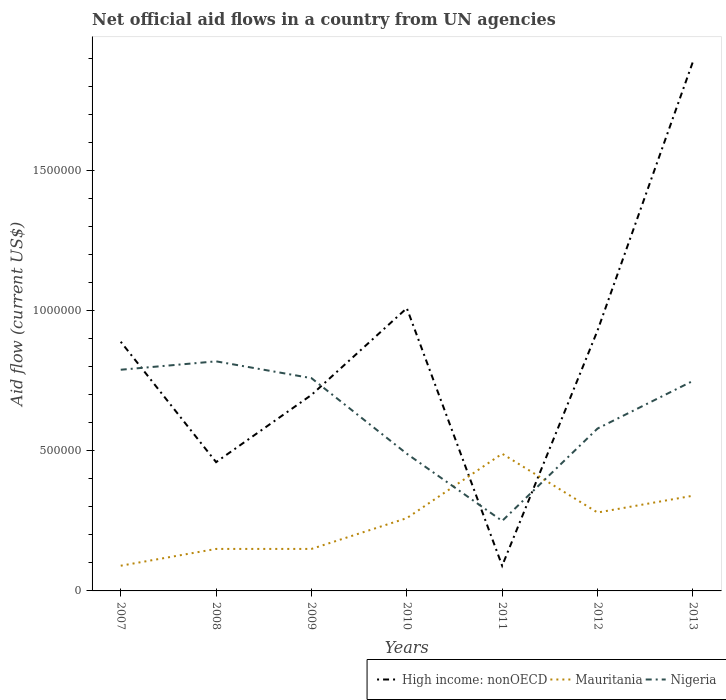How many different coloured lines are there?
Provide a succinct answer. 3. What is the total net official aid flow in Nigeria in the graph?
Offer a terse response. 5.10e+05. What is the difference between the highest and the second highest net official aid flow in High income: nonOECD?
Ensure brevity in your answer.  1.80e+06. What is the difference between the highest and the lowest net official aid flow in Mauritania?
Your answer should be very brief. 4. How many years are there in the graph?
Provide a short and direct response. 7. What is the difference between two consecutive major ticks on the Y-axis?
Provide a succinct answer. 5.00e+05. Does the graph contain any zero values?
Offer a terse response. No. Where does the legend appear in the graph?
Make the answer very short. Bottom right. How are the legend labels stacked?
Give a very brief answer. Horizontal. What is the title of the graph?
Your answer should be compact. Net official aid flows in a country from UN agencies. Does "South Africa" appear as one of the legend labels in the graph?
Your response must be concise. No. What is the label or title of the Y-axis?
Keep it short and to the point. Aid flow (current US$). What is the Aid flow (current US$) in High income: nonOECD in 2007?
Make the answer very short. 8.90e+05. What is the Aid flow (current US$) in Mauritania in 2007?
Offer a terse response. 9.00e+04. What is the Aid flow (current US$) in Nigeria in 2007?
Your answer should be very brief. 7.90e+05. What is the Aid flow (current US$) in Nigeria in 2008?
Provide a succinct answer. 8.20e+05. What is the Aid flow (current US$) in Mauritania in 2009?
Provide a succinct answer. 1.50e+05. What is the Aid flow (current US$) of Nigeria in 2009?
Your answer should be compact. 7.60e+05. What is the Aid flow (current US$) in High income: nonOECD in 2010?
Ensure brevity in your answer.  1.01e+06. What is the Aid flow (current US$) in Nigeria in 2010?
Your response must be concise. 4.90e+05. What is the Aid flow (current US$) in High income: nonOECD in 2011?
Your answer should be very brief. 9.00e+04. What is the Aid flow (current US$) in Nigeria in 2011?
Make the answer very short. 2.50e+05. What is the Aid flow (current US$) in High income: nonOECD in 2012?
Offer a very short reply. 9.30e+05. What is the Aid flow (current US$) of Nigeria in 2012?
Offer a very short reply. 5.80e+05. What is the Aid flow (current US$) of High income: nonOECD in 2013?
Keep it short and to the point. 1.89e+06. What is the Aid flow (current US$) of Mauritania in 2013?
Provide a succinct answer. 3.40e+05. What is the Aid flow (current US$) of Nigeria in 2013?
Offer a terse response. 7.50e+05. Across all years, what is the maximum Aid flow (current US$) of High income: nonOECD?
Make the answer very short. 1.89e+06. Across all years, what is the maximum Aid flow (current US$) in Mauritania?
Ensure brevity in your answer.  4.90e+05. Across all years, what is the maximum Aid flow (current US$) of Nigeria?
Provide a short and direct response. 8.20e+05. Across all years, what is the minimum Aid flow (current US$) of Nigeria?
Ensure brevity in your answer.  2.50e+05. What is the total Aid flow (current US$) of High income: nonOECD in the graph?
Your answer should be compact. 5.97e+06. What is the total Aid flow (current US$) of Mauritania in the graph?
Offer a very short reply. 1.76e+06. What is the total Aid flow (current US$) in Nigeria in the graph?
Keep it short and to the point. 4.44e+06. What is the difference between the Aid flow (current US$) of Mauritania in 2007 and that in 2008?
Your answer should be compact. -6.00e+04. What is the difference between the Aid flow (current US$) of Nigeria in 2007 and that in 2008?
Make the answer very short. -3.00e+04. What is the difference between the Aid flow (current US$) in High income: nonOECD in 2007 and that in 2009?
Give a very brief answer. 1.90e+05. What is the difference between the Aid flow (current US$) of Mauritania in 2007 and that in 2009?
Provide a short and direct response. -6.00e+04. What is the difference between the Aid flow (current US$) in High income: nonOECD in 2007 and that in 2010?
Provide a short and direct response. -1.20e+05. What is the difference between the Aid flow (current US$) in Mauritania in 2007 and that in 2010?
Offer a terse response. -1.70e+05. What is the difference between the Aid flow (current US$) of Mauritania in 2007 and that in 2011?
Provide a short and direct response. -4.00e+05. What is the difference between the Aid flow (current US$) of Nigeria in 2007 and that in 2011?
Your answer should be compact. 5.40e+05. What is the difference between the Aid flow (current US$) in High income: nonOECD in 2007 and that in 2012?
Offer a terse response. -4.00e+04. What is the difference between the Aid flow (current US$) in Mauritania in 2007 and that in 2013?
Ensure brevity in your answer.  -2.50e+05. What is the difference between the Aid flow (current US$) of Nigeria in 2008 and that in 2009?
Your answer should be compact. 6.00e+04. What is the difference between the Aid flow (current US$) in High income: nonOECD in 2008 and that in 2010?
Provide a succinct answer. -5.50e+05. What is the difference between the Aid flow (current US$) in Nigeria in 2008 and that in 2011?
Offer a terse response. 5.70e+05. What is the difference between the Aid flow (current US$) in High income: nonOECD in 2008 and that in 2012?
Ensure brevity in your answer.  -4.70e+05. What is the difference between the Aid flow (current US$) in Nigeria in 2008 and that in 2012?
Your answer should be compact. 2.40e+05. What is the difference between the Aid flow (current US$) of High income: nonOECD in 2008 and that in 2013?
Provide a short and direct response. -1.43e+06. What is the difference between the Aid flow (current US$) in Mauritania in 2008 and that in 2013?
Your answer should be compact. -1.90e+05. What is the difference between the Aid flow (current US$) in Nigeria in 2008 and that in 2013?
Your answer should be compact. 7.00e+04. What is the difference between the Aid flow (current US$) of High income: nonOECD in 2009 and that in 2010?
Give a very brief answer. -3.10e+05. What is the difference between the Aid flow (current US$) in Mauritania in 2009 and that in 2010?
Your response must be concise. -1.10e+05. What is the difference between the Aid flow (current US$) of Nigeria in 2009 and that in 2010?
Offer a very short reply. 2.70e+05. What is the difference between the Aid flow (current US$) of High income: nonOECD in 2009 and that in 2011?
Provide a short and direct response. 6.10e+05. What is the difference between the Aid flow (current US$) of Nigeria in 2009 and that in 2011?
Ensure brevity in your answer.  5.10e+05. What is the difference between the Aid flow (current US$) in High income: nonOECD in 2009 and that in 2013?
Ensure brevity in your answer.  -1.19e+06. What is the difference between the Aid flow (current US$) in Nigeria in 2009 and that in 2013?
Offer a very short reply. 10000. What is the difference between the Aid flow (current US$) of High income: nonOECD in 2010 and that in 2011?
Offer a very short reply. 9.20e+05. What is the difference between the Aid flow (current US$) in Mauritania in 2010 and that in 2011?
Your answer should be compact. -2.30e+05. What is the difference between the Aid flow (current US$) of High income: nonOECD in 2010 and that in 2012?
Your answer should be compact. 8.00e+04. What is the difference between the Aid flow (current US$) of High income: nonOECD in 2010 and that in 2013?
Offer a very short reply. -8.80e+05. What is the difference between the Aid flow (current US$) in Mauritania in 2010 and that in 2013?
Your answer should be compact. -8.00e+04. What is the difference between the Aid flow (current US$) of Nigeria in 2010 and that in 2013?
Offer a very short reply. -2.60e+05. What is the difference between the Aid flow (current US$) in High income: nonOECD in 2011 and that in 2012?
Offer a terse response. -8.40e+05. What is the difference between the Aid flow (current US$) of Mauritania in 2011 and that in 2012?
Your answer should be compact. 2.10e+05. What is the difference between the Aid flow (current US$) of Nigeria in 2011 and that in 2012?
Your response must be concise. -3.30e+05. What is the difference between the Aid flow (current US$) of High income: nonOECD in 2011 and that in 2013?
Offer a very short reply. -1.80e+06. What is the difference between the Aid flow (current US$) of Nigeria in 2011 and that in 2013?
Your response must be concise. -5.00e+05. What is the difference between the Aid flow (current US$) in High income: nonOECD in 2012 and that in 2013?
Keep it short and to the point. -9.60e+05. What is the difference between the Aid flow (current US$) of High income: nonOECD in 2007 and the Aid flow (current US$) of Mauritania in 2008?
Offer a terse response. 7.40e+05. What is the difference between the Aid flow (current US$) of Mauritania in 2007 and the Aid flow (current US$) of Nigeria in 2008?
Offer a very short reply. -7.30e+05. What is the difference between the Aid flow (current US$) of High income: nonOECD in 2007 and the Aid flow (current US$) of Mauritania in 2009?
Ensure brevity in your answer.  7.40e+05. What is the difference between the Aid flow (current US$) in High income: nonOECD in 2007 and the Aid flow (current US$) in Nigeria in 2009?
Provide a succinct answer. 1.30e+05. What is the difference between the Aid flow (current US$) of Mauritania in 2007 and the Aid flow (current US$) of Nigeria in 2009?
Provide a succinct answer. -6.70e+05. What is the difference between the Aid flow (current US$) of High income: nonOECD in 2007 and the Aid flow (current US$) of Mauritania in 2010?
Ensure brevity in your answer.  6.30e+05. What is the difference between the Aid flow (current US$) in Mauritania in 2007 and the Aid flow (current US$) in Nigeria in 2010?
Keep it short and to the point. -4.00e+05. What is the difference between the Aid flow (current US$) of High income: nonOECD in 2007 and the Aid flow (current US$) of Mauritania in 2011?
Provide a succinct answer. 4.00e+05. What is the difference between the Aid flow (current US$) in High income: nonOECD in 2007 and the Aid flow (current US$) in Nigeria in 2011?
Your response must be concise. 6.40e+05. What is the difference between the Aid flow (current US$) of Mauritania in 2007 and the Aid flow (current US$) of Nigeria in 2012?
Your answer should be very brief. -4.90e+05. What is the difference between the Aid flow (current US$) of High income: nonOECD in 2007 and the Aid flow (current US$) of Nigeria in 2013?
Provide a short and direct response. 1.40e+05. What is the difference between the Aid flow (current US$) in Mauritania in 2007 and the Aid flow (current US$) in Nigeria in 2013?
Ensure brevity in your answer.  -6.60e+05. What is the difference between the Aid flow (current US$) in High income: nonOECD in 2008 and the Aid flow (current US$) in Mauritania in 2009?
Your answer should be very brief. 3.10e+05. What is the difference between the Aid flow (current US$) of Mauritania in 2008 and the Aid flow (current US$) of Nigeria in 2009?
Keep it short and to the point. -6.10e+05. What is the difference between the Aid flow (current US$) in High income: nonOECD in 2008 and the Aid flow (current US$) in Mauritania in 2010?
Your answer should be compact. 2.00e+05. What is the difference between the Aid flow (current US$) in Mauritania in 2008 and the Aid flow (current US$) in Nigeria in 2010?
Provide a succinct answer. -3.40e+05. What is the difference between the Aid flow (current US$) of High income: nonOECD in 2008 and the Aid flow (current US$) of Mauritania in 2011?
Offer a terse response. -3.00e+04. What is the difference between the Aid flow (current US$) of Mauritania in 2008 and the Aid flow (current US$) of Nigeria in 2011?
Ensure brevity in your answer.  -1.00e+05. What is the difference between the Aid flow (current US$) of Mauritania in 2008 and the Aid flow (current US$) of Nigeria in 2012?
Your response must be concise. -4.30e+05. What is the difference between the Aid flow (current US$) in High income: nonOECD in 2008 and the Aid flow (current US$) in Mauritania in 2013?
Your answer should be compact. 1.20e+05. What is the difference between the Aid flow (current US$) in High income: nonOECD in 2008 and the Aid flow (current US$) in Nigeria in 2013?
Your response must be concise. -2.90e+05. What is the difference between the Aid flow (current US$) in Mauritania in 2008 and the Aid flow (current US$) in Nigeria in 2013?
Ensure brevity in your answer.  -6.00e+05. What is the difference between the Aid flow (current US$) of High income: nonOECD in 2009 and the Aid flow (current US$) of Nigeria in 2010?
Keep it short and to the point. 2.10e+05. What is the difference between the Aid flow (current US$) of High income: nonOECD in 2009 and the Aid flow (current US$) of Mauritania in 2011?
Give a very brief answer. 2.10e+05. What is the difference between the Aid flow (current US$) of High income: nonOECD in 2009 and the Aid flow (current US$) of Mauritania in 2012?
Make the answer very short. 4.20e+05. What is the difference between the Aid flow (current US$) of High income: nonOECD in 2009 and the Aid flow (current US$) of Nigeria in 2012?
Provide a succinct answer. 1.20e+05. What is the difference between the Aid flow (current US$) in Mauritania in 2009 and the Aid flow (current US$) in Nigeria in 2012?
Your response must be concise. -4.30e+05. What is the difference between the Aid flow (current US$) in Mauritania in 2009 and the Aid flow (current US$) in Nigeria in 2013?
Provide a short and direct response. -6.00e+05. What is the difference between the Aid flow (current US$) of High income: nonOECD in 2010 and the Aid flow (current US$) of Mauritania in 2011?
Offer a terse response. 5.20e+05. What is the difference between the Aid flow (current US$) in High income: nonOECD in 2010 and the Aid flow (current US$) in Nigeria in 2011?
Your response must be concise. 7.60e+05. What is the difference between the Aid flow (current US$) of High income: nonOECD in 2010 and the Aid flow (current US$) of Mauritania in 2012?
Your answer should be very brief. 7.30e+05. What is the difference between the Aid flow (current US$) of High income: nonOECD in 2010 and the Aid flow (current US$) of Nigeria in 2012?
Provide a short and direct response. 4.30e+05. What is the difference between the Aid flow (current US$) of Mauritania in 2010 and the Aid flow (current US$) of Nigeria in 2012?
Provide a succinct answer. -3.20e+05. What is the difference between the Aid flow (current US$) of High income: nonOECD in 2010 and the Aid flow (current US$) of Mauritania in 2013?
Your answer should be very brief. 6.70e+05. What is the difference between the Aid flow (current US$) in Mauritania in 2010 and the Aid flow (current US$) in Nigeria in 2013?
Provide a short and direct response. -4.90e+05. What is the difference between the Aid flow (current US$) of High income: nonOECD in 2011 and the Aid flow (current US$) of Nigeria in 2012?
Provide a succinct answer. -4.90e+05. What is the difference between the Aid flow (current US$) in High income: nonOECD in 2011 and the Aid flow (current US$) in Nigeria in 2013?
Your answer should be compact. -6.60e+05. What is the difference between the Aid flow (current US$) of High income: nonOECD in 2012 and the Aid flow (current US$) of Mauritania in 2013?
Offer a terse response. 5.90e+05. What is the difference between the Aid flow (current US$) of High income: nonOECD in 2012 and the Aid flow (current US$) of Nigeria in 2013?
Provide a succinct answer. 1.80e+05. What is the difference between the Aid flow (current US$) in Mauritania in 2012 and the Aid flow (current US$) in Nigeria in 2013?
Make the answer very short. -4.70e+05. What is the average Aid flow (current US$) in High income: nonOECD per year?
Ensure brevity in your answer.  8.53e+05. What is the average Aid flow (current US$) of Mauritania per year?
Ensure brevity in your answer.  2.51e+05. What is the average Aid flow (current US$) of Nigeria per year?
Ensure brevity in your answer.  6.34e+05. In the year 2007, what is the difference between the Aid flow (current US$) of Mauritania and Aid flow (current US$) of Nigeria?
Make the answer very short. -7.00e+05. In the year 2008, what is the difference between the Aid flow (current US$) in High income: nonOECD and Aid flow (current US$) in Mauritania?
Your response must be concise. 3.10e+05. In the year 2008, what is the difference between the Aid flow (current US$) of High income: nonOECD and Aid flow (current US$) of Nigeria?
Your response must be concise. -3.60e+05. In the year 2008, what is the difference between the Aid flow (current US$) of Mauritania and Aid flow (current US$) of Nigeria?
Ensure brevity in your answer.  -6.70e+05. In the year 2009, what is the difference between the Aid flow (current US$) of Mauritania and Aid flow (current US$) of Nigeria?
Give a very brief answer. -6.10e+05. In the year 2010, what is the difference between the Aid flow (current US$) of High income: nonOECD and Aid flow (current US$) of Mauritania?
Keep it short and to the point. 7.50e+05. In the year 2010, what is the difference between the Aid flow (current US$) of High income: nonOECD and Aid flow (current US$) of Nigeria?
Ensure brevity in your answer.  5.20e+05. In the year 2011, what is the difference between the Aid flow (current US$) in High income: nonOECD and Aid flow (current US$) in Mauritania?
Provide a short and direct response. -4.00e+05. In the year 2011, what is the difference between the Aid flow (current US$) of High income: nonOECD and Aid flow (current US$) of Nigeria?
Make the answer very short. -1.60e+05. In the year 2012, what is the difference between the Aid flow (current US$) in High income: nonOECD and Aid flow (current US$) in Mauritania?
Offer a very short reply. 6.50e+05. In the year 2012, what is the difference between the Aid flow (current US$) in Mauritania and Aid flow (current US$) in Nigeria?
Offer a terse response. -3.00e+05. In the year 2013, what is the difference between the Aid flow (current US$) of High income: nonOECD and Aid flow (current US$) of Mauritania?
Ensure brevity in your answer.  1.55e+06. In the year 2013, what is the difference between the Aid flow (current US$) in High income: nonOECD and Aid flow (current US$) in Nigeria?
Your response must be concise. 1.14e+06. In the year 2013, what is the difference between the Aid flow (current US$) of Mauritania and Aid flow (current US$) of Nigeria?
Provide a succinct answer. -4.10e+05. What is the ratio of the Aid flow (current US$) in High income: nonOECD in 2007 to that in 2008?
Keep it short and to the point. 1.93. What is the ratio of the Aid flow (current US$) in Mauritania in 2007 to that in 2008?
Offer a very short reply. 0.6. What is the ratio of the Aid flow (current US$) in Nigeria in 2007 to that in 2008?
Your answer should be compact. 0.96. What is the ratio of the Aid flow (current US$) of High income: nonOECD in 2007 to that in 2009?
Ensure brevity in your answer.  1.27. What is the ratio of the Aid flow (current US$) in Mauritania in 2007 to that in 2009?
Keep it short and to the point. 0.6. What is the ratio of the Aid flow (current US$) of Nigeria in 2007 to that in 2009?
Make the answer very short. 1.04. What is the ratio of the Aid flow (current US$) of High income: nonOECD in 2007 to that in 2010?
Keep it short and to the point. 0.88. What is the ratio of the Aid flow (current US$) in Mauritania in 2007 to that in 2010?
Your answer should be very brief. 0.35. What is the ratio of the Aid flow (current US$) of Nigeria in 2007 to that in 2010?
Your response must be concise. 1.61. What is the ratio of the Aid flow (current US$) in High income: nonOECD in 2007 to that in 2011?
Make the answer very short. 9.89. What is the ratio of the Aid flow (current US$) of Mauritania in 2007 to that in 2011?
Offer a terse response. 0.18. What is the ratio of the Aid flow (current US$) in Nigeria in 2007 to that in 2011?
Make the answer very short. 3.16. What is the ratio of the Aid flow (current US$) of High income: nonOECD in 2007 to that in 2012?
Your response must be concise. 0.96. What is the ratio of the Aid flow (current US$) in Mauritania in 2007 to that in 2012?
Ensure brevity in your answer.  0.32. What is the ratio of the Aid flow (current US$) in Nigeria in 2007 to that in 2012?
Your response must be concise. 1.36. What is the ratio of the Aid flow (current US$) in High income: nonOECD in 2007 to that in 2013?
Provide a short and direct response. 0.47. What is the ratio of the Aid flow (current US$) in Mauritania in 2007 to that in 2013?
Your answer should be very brief. 0.26. What is the ratio of the Aid flow (current US$) in Nigeria in 2007 to that in 2013?
Your answer should be compact. 1.05. What is the ratio of the Aid flow (current US$) of High income: nonOECD in 2008 to that in 2009?
Give a very brief answer. 0.66. What is the ratio of the Aid flow (current US$) in Mauritania in 2008 to that in 2009?
Provide a succinct answer. 1. What is the ratio of the Aid flow (current US$) of Nigeria in 2008 to that in 2009?
Ensure brevity in your answer.  1.08. What is the ratio of the Aid flow (current US$) of High income: nonOECD in 2008 to that in 2010?
Give a very brief answer. 0.46. What is the ratio of the Aid flow (current US$) in Mauritania in 2008 to that in 2010?
Give a very brief answer. 0.58. What is the ratio of the Aid flow (current US$) in Nigeria in 2008 to that in 2010?
Your answer should be compact. 1.67. What is the ratio of the Aid flow (current US$) of High income: nonOECD in 2008 to that in 2011?
Your answer should be very brief. 5.11. What is the ratio of the Aid flow (current US$) in Mauritania in 2008 to that in 2011?
Provide a succinct answer. 0.31. What is the ratio of the Aid flow (current US$) of Nigeria in 2008 to that in 2011?
Provide a short and direct response. 3.28. What is the ratio of the Aid flow (current US$) in High income: nonOECD in 2008 to that in 2012?
Keep it short and to the point. 0.49. What is the ratio of the Aid flow (current US$) of Mauritania in 2008 to that in 2012?
Make the answer very short. 0.54. What is the ratio of the Aid flow (current US$) in Nigeria in 2008 to that in 2012?
Provide a short and direct response. 1.41. What is the ratio of the Aid flow (current US$) of High income: nonOECD in 2008 to that in 2013?
Keep it short and to the point. 0.24. What is the ratio of the Aid flow (current US$) in Mauritania in 2008 to that in 2013?
Your response must be concise. 0.44. What is the ratio of the Aid flow (current US$) in Nigeria in 2008 to that in 2013?
Your answer should be compact. 1.09. What is the ratio of the Aid flow (current US$) in High income: nonOECD in 2009 to that in 2010?
Provide a succinct answer. 0.69. What is the ratio of the Aid flow (current US$) of Mauritania in 2009 to that in 2010?
Ensure brevity in your answer.  0.58. What is the ratio of the Aid flow (current US$) of Nigeria in 2009 to that in 2010?
Ensure brevity in your answer.  1.55. What is the ratio of the Aid flow (current US$) of High income: nonOECD in 2009 to that in 2011?
Keep it short and to the point. 7.78. What is the ratio of the Aid flow (current US$) of Mauritania in 2009 to that in 2011?
Your answer should be very brief. 0.31. What is the ratio of the Aid flow (current US$) of Nigeria in 2009 to that in 2011?
Provide a succinct answer. 3.04. What is the ratio of the Aid flow (current US$) in High income: nonOECD in 2009 to that in 2012?
Your response must be concise. 0.75. What is the ratio of the Aid flow (current US$) of Mauritania in 2009 to that in 2012?
Offer a very short reply. 0.54. What is the ratio of the Aid flow (current US$) of Nigeria in 2009 to that in 2012?
Make the answer very short. 1.31. What is the ratio of the Aid flow (current US$) of High income: nonOECD in 2009 to that in 2013?
Provide a short and direct response. 0.37. What is the ratio of the Aid flow (current US$) in Mauritania in 2009 to that in 2013?
Your response must be concise. 0.44. What is the ratio of the Aid flow (current US$) of Nigeria in 2009 to that in 2013?
Provide a short and direct response. 1.01. What is the ratio of the Aid flow (current US$) of High income: nonOECD in 2010 to that in 2011?
Your answer should be compact. 11.22. What is the ratio of the Aid flow (current US$) of Mauritania in 2010 to that in 2011?
Give a very brief answer. 0.53. What is the ratio of the Aid flow (current US$) of Nigeria in 2010 to that in 2011?
Give a very brief answer. 1.96. What is the ratio of the Aid flow (current US$) of High income: nonOECD in 2010 to that in 2012?
Your answer should be very brief. 1.09. What is the ratio of the Aid flow (current US$) of Nigeria in 2010 to that in 2012?
Offer a very short reply. 0.84. What is the ratio of the Aid flow (current US$) of High income: nonOECD in 2010 to that in 2013?
Provide a short and direct response. 0.53. What is the ratio of the Aid flow (current US$) of Mauritania in 2010 to that in 2013?
Offer a terse response. 0.76. What is the ratio of the Aid flow (current US$) of Nigeria in 2010 to that in 2013?
Keep it short and to the point. 0.65. What is the ratio of the Aid flow (current US$) of High income: nonOECD in 2011 to that in 2012?
Give a very brief answer. 0.1. What is the ratio of the Aid flow (current US$) in Mauritania in 2011 to that in 2012?
Your answer should be compact. 1.75. What is the ratio of the Aid flow (current US$) in Nigeria in 2011 to that in 2012?
Keep it short and to the point. 0.43. What is the ratio of the Aid flow (current US$) in High income: nonOECD in 2011 to that in 2013?
Provide a short and direct response. 0.05. What is the ratio of the Aid flow (current US$) in Mauritania in 2011 to that in 2013?
Give a very brief answer. 1.44. What is the ratio of the Aid flow (current US$) of Nigeria in 2011 to that in 2013?
Your answer should be compact. 0.33. What is the ratio of the Aid flow (current US$) in High income: nonOECD in 2012 to that in 2013?
Offer a very short reply. 0.49. What is the ratio of the Aid flow (current US$) in Mauritania in 2012 to that in 2013?
Your response must be concise. 0.82. What is the ratio of the Aid flow (current US$) of Nigeria in 2012 to that in 2013?
Give a very brief answer. 0.77. What is the difference between the highest and the second highest Aid flow (current US$) in High income: nonOECD?
Offer a terse response. 8.80e+05. What is the difference between the highest and the second highest Aid flow (current US$) in Mauritania?
Your answer should be very brief. 1.50e+05. What is the difference between the highest and the lowest Aid flow (current US$) of High income: nonOECD?
Keep it short and to the point. 1.80e+06. What is the difference between the highest and the lowest Aid flow (current US$) of Nigeria?
Provide a succinct answer. 5.70e+05. 